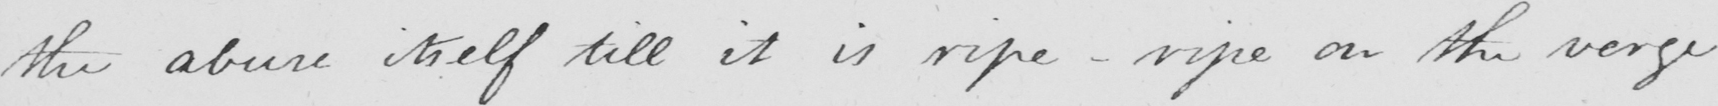Please transcribe the handwritten text in this image. the abuse itself till it is ripe  _  ripe on the verge 